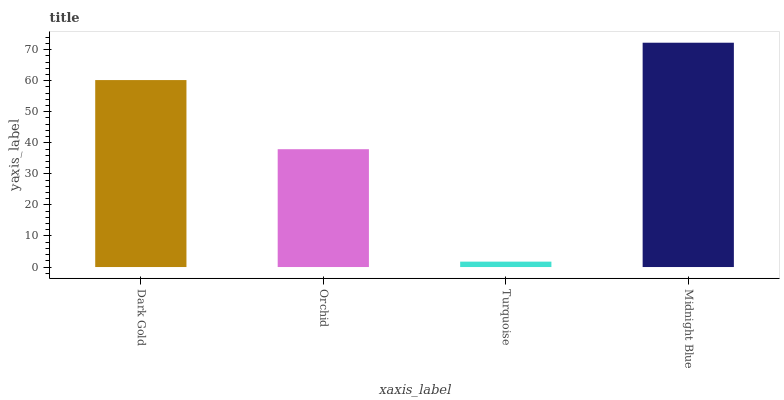Is Turquoise the minimum?
Answer yes or no. Yes. Is Midnight Blue the maximum?
Answer yes or no. Yes. Is Orchid the minimum?
Answer yes or no. No. Is Orchid the maximum?
Answer yes or no. No. Is Dark Gold greater than Orchid?
Answer yes or no. Yes. Is Orchid less than Dark Gold?
Answer yes or no. Yes. Is Orchid greater than Dark Gold?
Answer yes or no. No. Is Dark Gold less than Orchid?
Answer yes or no. No. Is Dark Gold the high median?
Answer yes or no. Yes. Is Orchid the low median?
Answer yes or no. Yes. Is Orchid the high median?
Answer yes or no. No. Is Turquoise the low median?
Answer yes or no. No. 